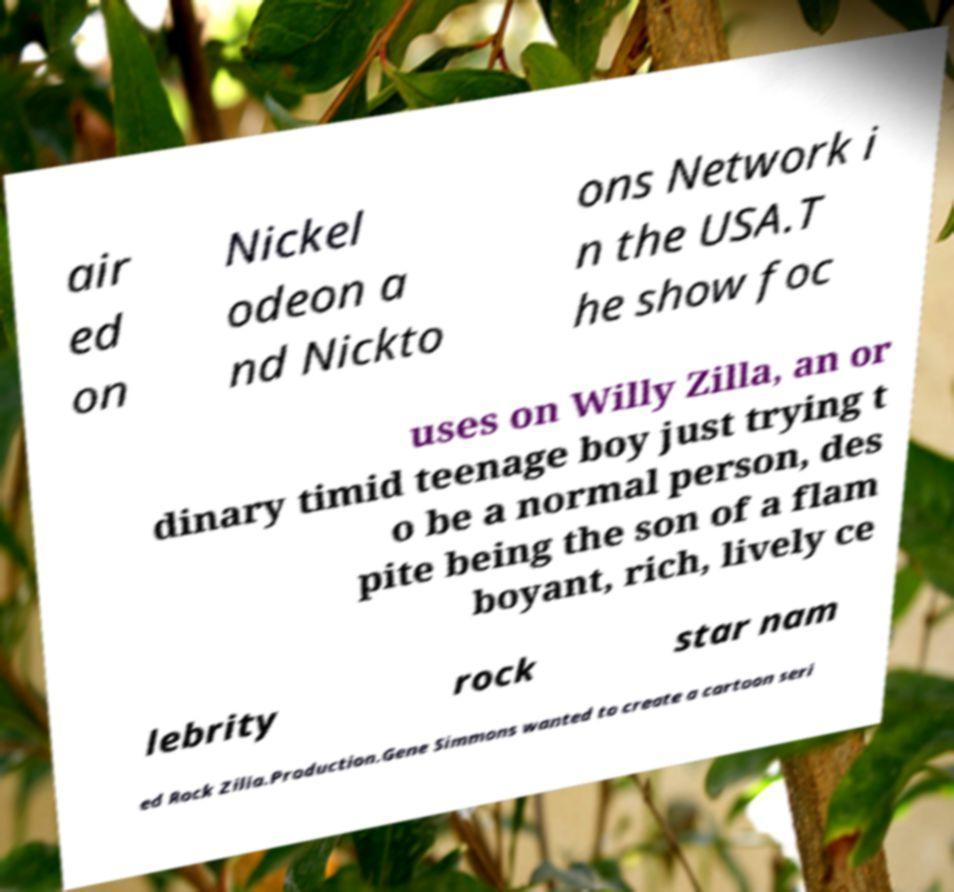Can you accurately transcribe the text from the provided image for me? air ed on Nickel odeon a nd Nickto ons Network i n the USA.T he show foc uses on Willy Zilla, an or dinary timid teenage boy just trying t o be a normal person, des pite being the son of a flam boyant, rich, lively ce lebrity rock star nam ed Rock Zilla.Production.Gene Simmons wanted to create a cartoon seri 